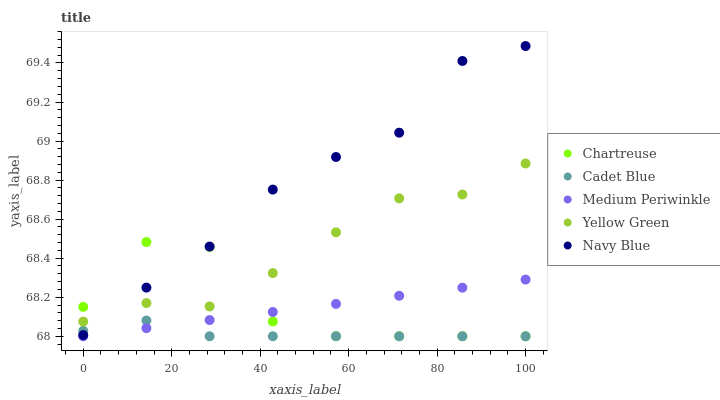Does Cadet Blue have the minimum area under the curve?
Answer yes or no. Yes. Does Navy Blue have the maximum area under the curve?
Answer yes or no. Yes. Does Chartreuse have the minimum area under the curve?
Answer yes or no. No. Does Chartreuse have the maximum area under the curve?
Answer yes or no. No. Is Medium Periwinkle the smoothest?
Answer yes or no. Yes. Is Chartreuse the roughest?
Answer yes or no. Yes. Is Cadet Blue the smoothest?
Answer yes or no. No. Is Cadet Blue the roughest?
Answer yes or no. No. Does Chartreuse have the lowest value?
Answer yes or no. Yes. Does Yellow Green have the lowest value?
Answer yes or no. No. Does Navy Blue have the highest value?
Answer yes or no. Yes. Does Chartreuse have the highest value?
Answer yes or no. No. Is Cadet Blue less than Yellow Green?
Answer yes or no. Yes. Is Yellow Green greater than Cadet Blue?
Answer yes or no. Yes. Does Medium Periwinkle intersect Chartreuse?
Answer yes or no. Yes. Is Medium Periwinkle less than Chartreuse?
Answer yes or no. No. Is Medium Periwinkle greater than Chartreuse?
Answer yes or no. No. Does Cadet Blue intersect Yellow Green?
Answer yes or no. No. 